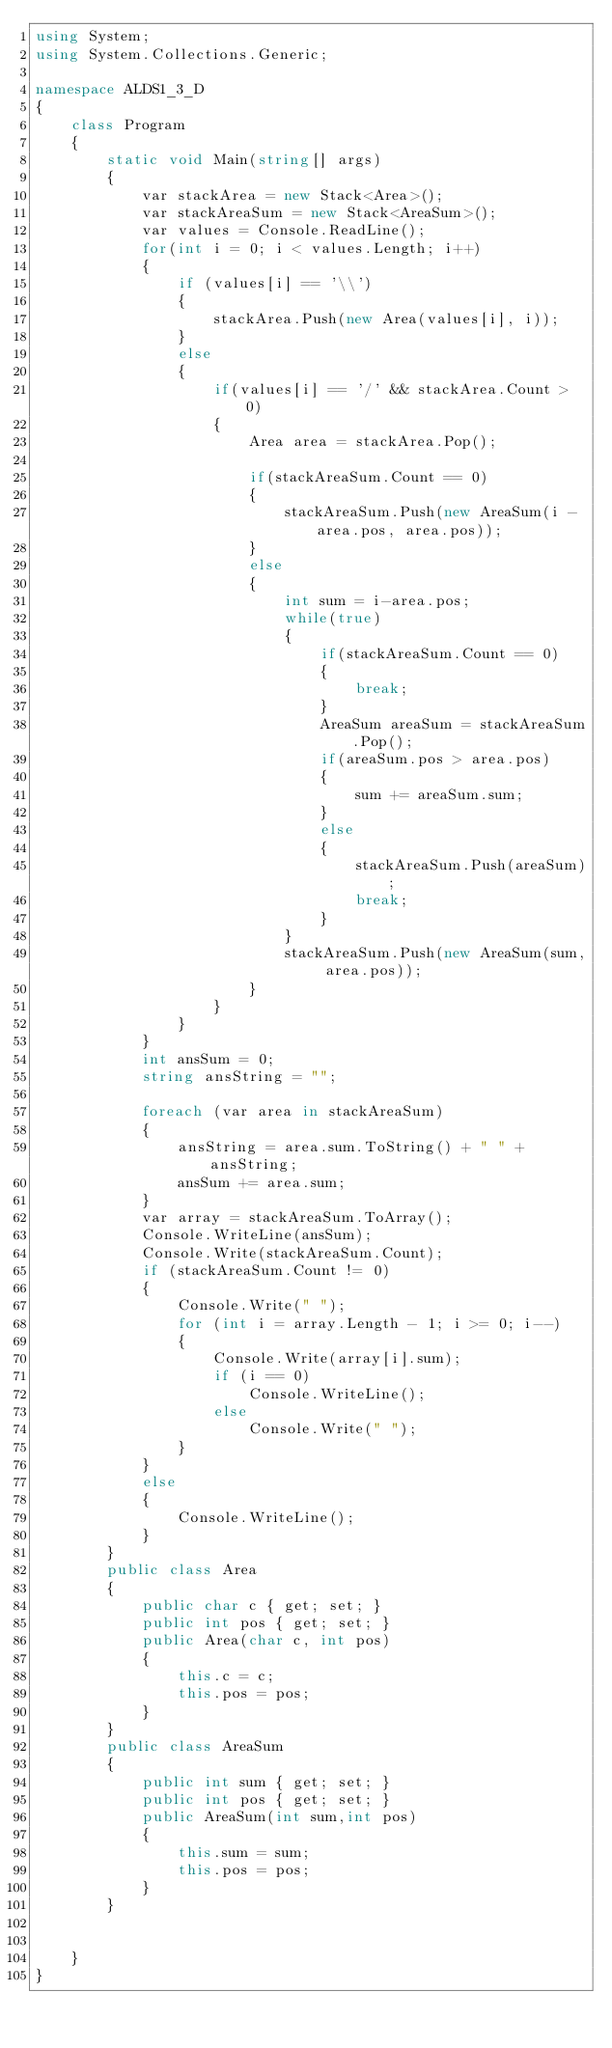<code> <loc_0><loc_0><loc_500><loc_500><_C#_>using System;
using System.Collections.Generic;

namespace ALDS1_3_D
{
    class Program
    {
        static void Main(string[] args)
        {
            var stackArea = new Stack<Area>();
            var stackAreaSum = new Stack<AreaSum>();
            var values = Console.ReadLine();
            for(int i = 0; i < values.Length; i++)
            {
                if (values[i] == '\\')
                {
                    stackArea.Push(new Area(values[i], i));
                }
                else
                {
                    if(values[i] == '/' && stackArea.Count > 0)
                    {
                        Area area = stackArea.Pop();
                        
                        if(stackAreaSum.Count == 0)
                        {
                            stackAreaSum.Push(new AreaSum(i - area.pos, area.pos));
                        }
                        else
                        {
                            int sum = i-area.pos;
                            while(true)
                            {
                                if(stackAreaSum.Count == 0)
                                {
                                    break;
                                }
                                AreaSum areaSum = stackAreaSum.Pop();
                                if(areaSum.pos > area.pos)
                                {
                                    sum += areaSum.sum;
                                }
                                else
                                {
                                    stackAreaSum.Push(areaSum);
                                    break;
                                }
                            }
                            stackAreaSum.Push(new AreaSum(sum, area.pos));
                        }
                    }
                }
            }
            int ansSum = 0;
            string ansString = "";
            
            foreach (var area in stackAreaSum)
            {
                ansString = area.sum.ToString() + " " + ansString;
                ansSum += area.sum;
            }
            var array = stackAreaSum.ToArray();
            Console.WriteLine(ansSum);
            Console.Write(stackAreaSum.Count);
            if (stackAreaSum.Count != 0)
            {
                Console.Write(" ");
                for (int i = array.Length - 1; i >= 0; i--)
                {
                    Console.Write(array[i].sum);
                    if (i == 0)
                        Console.WriteLine();
                    else
                        Console.Write(" ");
                }
            }
            else
            {
                Console.WriteLine();
            }
        }
        public class Area
        {
            public char c { get; set; }
            public int pos { get; set; }
            public Area(char c, int pos)
            {
                this.c = c;
                this.pos = pos;
            }
        }
        public class AreaSum
        {
            public int sum { get; set; }
            public int pos { get; set; }
            public AreaSum(int sum,int pos)
            {
                this.sum = sum;
                this.pos = pos;
            }
        }


    }
}

</code> 